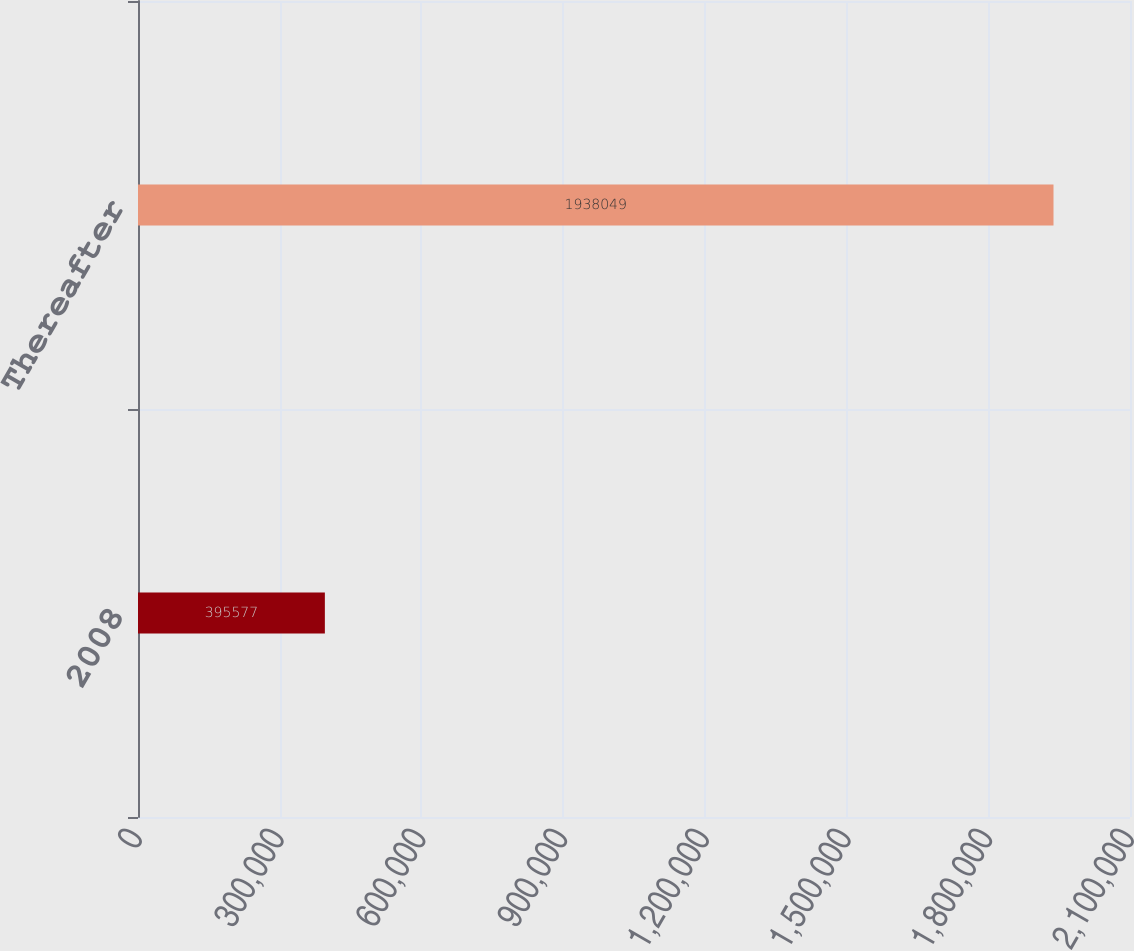Convert chart to OTSL. <chart><loc_0><loc_0><loc_500><loc_500><bar_chart><fcel>2008<fcel>Thereafter<nl><fcel>395577<fcel>1.93805e+06<nl></chart> 